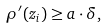Convert formula to latex. <formula><loc_0><loc_0><loc_500><loc_500>\rho ^ { \prime } ( z _ { i } ) \geq a \cdot \delta ,</formula> 